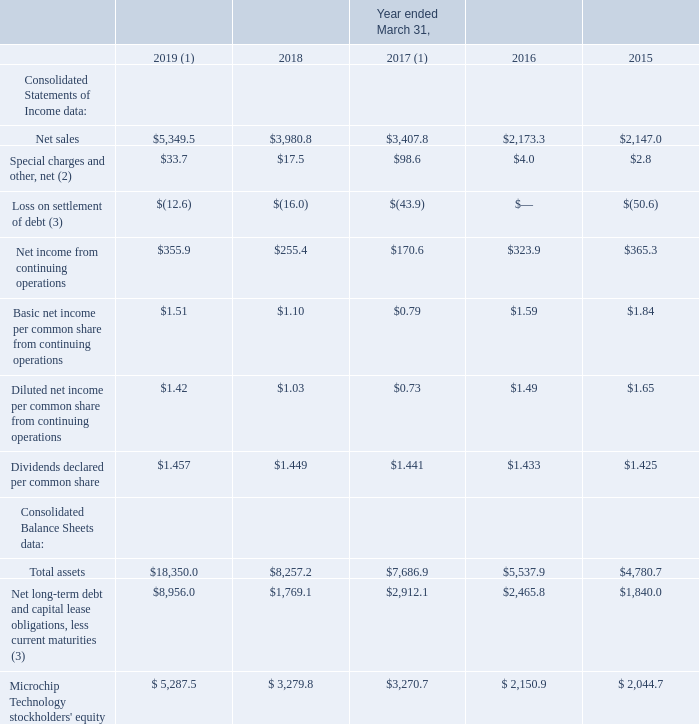Item 6. SELECTED FINANCIAL DATA
You should read the following selected consolidated financial data for the five-year period ended March 31, 2019 in conjunction with our consolidated financial statements and notes thereto and "Management's Discussion and Analysis of Financial Condition and Results of Operations" included in Items 7 and 8 of this Form 10-K. Our consolidated statements of income data for each of the years in the three-year period ended March 31, 2019, and the balance sheet data as of March 31, 2019 and 2018, are derived from our audited consolidated financial statements, included in Item 8 of this Form 10-K. The statement of income data for the years ended March 31, 2016 and 2015 and balance sheet data as of March 31, 2017, 2016 and 2015 have been derived from our audited consolidated financial statements not included herein (in the tables below all amounts are in millions, except per share data).
(1) Refer to Note 2 to our consolidated financial statements for an explanation of our material business combinations during fiscal 2019 and fiscal 2017.
(2) Refer to Note 4 to our consolidated financial statements for a discussion of the special charges and other, net.
(3) Refer to Note 12 Debt and Credit Facility for further discussion.
Which years does the table provide information for the company's consolidated balance sheets? 2019, 2018, 2017, 2016, 2015. What were the net sales in 2016?
Answer scale should be: million. 2,173.3. What was the loss on settlement of debt in 2019?
Answer scale should be: million. (12.6). What was the change in net sales between 2016 and 2017?
Answer scale should be: million. 3,407.8-2,173.3
Answer: 1234.5. How many years did Total Assets exceed $10,000 million? 2019
Answer: 1. What was the percentage change in the Net income from continuing operations between 2018 and 2019?
Answer scale should be: percent. (355.9-255.4)/255.4
Answer: 39.35. 